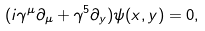Convert formula to latex. <formula><loc_0><loc_0><loc_500><loc_500>( i \gamma ^ { \mu } \partial _ { \mu } + \gamma ^ { 5 } \partial _ { y } ) \psi ( x , y ) = 0 ,</formula> 